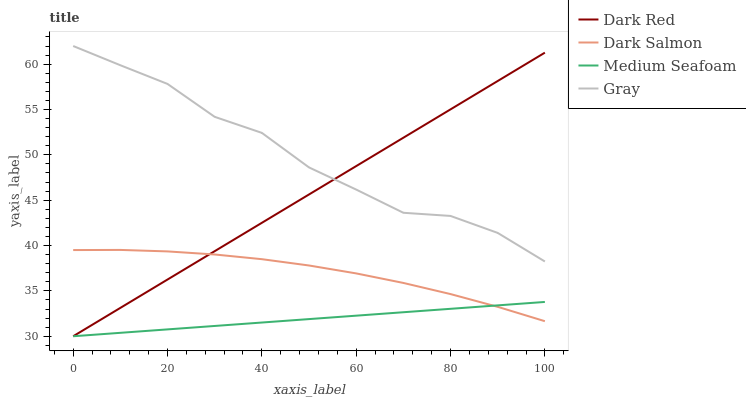Does Medium Seafoam have the minimum area under the curve?
Answer yes or no. Yes. Does Gray have the maximum area under the curve?
Answer yes or no. Yes. Does Dark Salmon have the minimum area under the curve?
Answer yes or no. No. Does Dark Salmon have the maximum area under the curve?
Answer yes or no. No. Is Medium Seafoam the smoothest?
Answer yes or no. Yes. Is Gray the roughest?
Answer yes or no. Yes. Is Dark Salmon the smoothest?
Answer yes or no. No. Is Dark Salmon the roughest?
Answer yes or no. No. Does Dark Red have the lowest value?
Answer yes or no. Yes. Does Dark Salmon have the lowest value?
Answer yes or no. No. Does Gray have the highest value?
Answer yes or no. Yes. Does Dark Salmon have the highest value?
Answer yes or no. No. Is Medium Seafoam less than Gray?
Answer yes or no. Yes. Is Gray greater than Medium Seafoam?
Answer yes or no. Yes. Does Dark Red intersect Gray?
Answer yes or no. Yes. Is Dark Red less than Gray?
Answer yes or no. No. Is Dark Red greater than Gray?
Answer yes or no. No. Does Medium Seafoam intersect Gray?
Answer yes or no. No. 